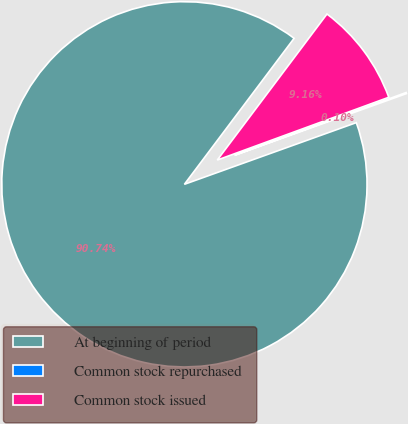Convert chart to OTSL. <chart><loc_0><loc_0><loc_500><loc_500><pie_chart><fcel>At beginning of period<fcel>Common stock repurchased<fcel>Common stock issued<nl><fcel>90.73%<fcel>0.1%<fcel>9.16%<nl></chart> 